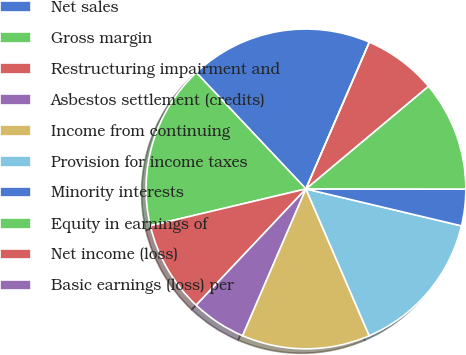<chart> <loc_0><loc_0><loc_500><loc_500><pie_chart><fcel>Net sales<fcel>Gross margin<fcel>Restructuring impairment and<fcel>Asbestos settlement (credits)<fcel>Income from continuing<fcel>Provision for income taxes<fcel>Minority interests<fcel>Equity in earnings of<fcel>Net income (loss)<fcel>Basic earnings (loss) per<nl><fcel>18.52%<fcel>16.67%<fcel>9.26%<fcel>5.56%<fcel>12.96%<fcel>14.81%<fcel>3.7%<fcel>11.11%<fcel>7.41%<fcel>0.0%<nl></chart> 